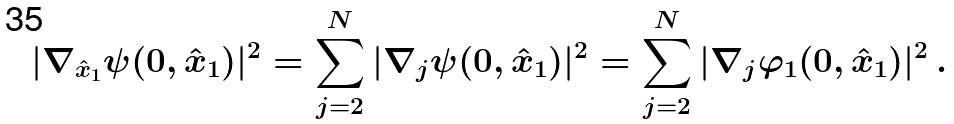<formula> <loc_0><loc_0><loc_500><loc_500>| \nabla _ { \hat { x } _ { 1 } } \psi ( 0 , \hat { x } _ { 1 } ) | ^ { 2 } = \sum _ { j = 2 } ^ { N } | \nabla _ { j } \psi ( 0 , \hat { x } _ { 1 } ) | ^ { 2 } = \sum _ { j = 2 } ^ { N } | \nabla _ { j } \varphi _ { 1 } ( 0 , \hat { x } _ { 1 } ) | ^ { 2 } \, .</formula> 